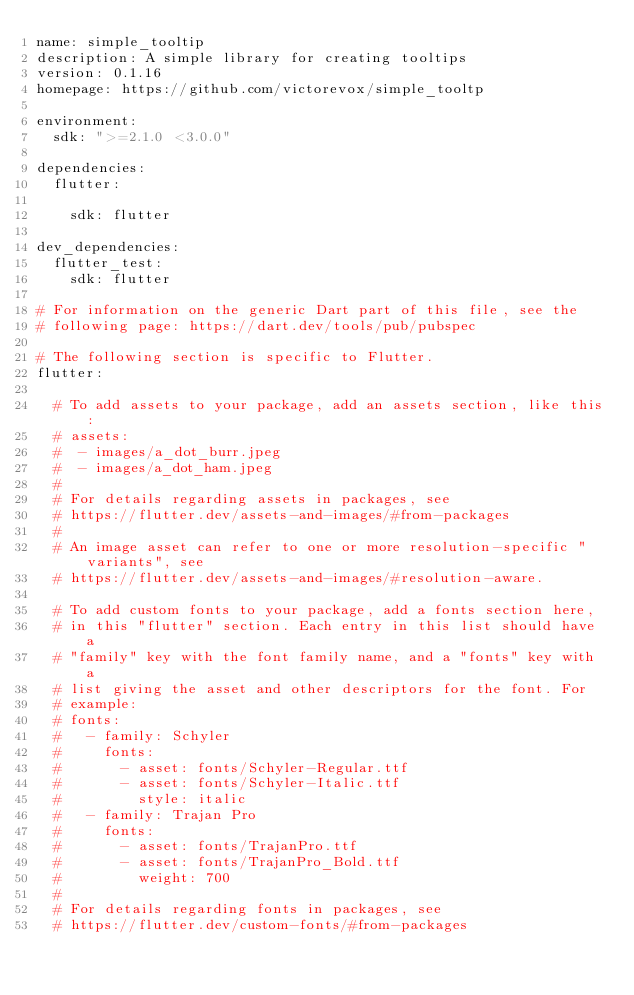Convert code to text. <code><loc_0><loc_0><loc_500><loc_500><_YAML_>name: simple_tooltip
description: A simple library for creating tooltips
version: 0.1.16
homepage: https://github.com/victorevox/simple_tooltp

environment:
  sdk: ">=2.1.0 <3.0.0"

dependencies:
  flutter:
    
    sdk: flutter

dev_dependencies:
  flutter_test:
    sdk: flutter

# For information on the generic Dart part of this file, see the
# following page: https://dart.dev/tools/pub/pubspec

# The following section is specific to Flutter.
flutter:

  # To add assets to your package, add an assets section, like this:
  # assets:
  #  - images/a_dot_burr.jpeg
  #  - images/a_dot_ham.jpeg
  #
  # For details regarding assets in packages, see
  # https://flutter.dev/assets-and-images/#from-packages
  #
  # An image asset can refer to one or more resolution-specific "variants", see
  # https://flutter.dev/assets-and-images/#resolution-aware.

  # To add custom fonts to your package, add a fonts section here,
  # in this "flutter" section. Each entry in this list should have a
  # "family" key with the font family name, and a "fonts" key with a
  # list giving the asset and other descriptors for the font. For
  # example:
  # fonts:
  #   - family: Schyler
  #     fonts:
  #       - asset: fonts/Schyler-Regular.ttf
  #       - asset: fonts/Schyler-Italic.ttf
  #         style: italic
  #   - family: Trajan Pro
  #     fonts:
  #       - asset: fonts/TrajanPro.ttf
  #       - asset: fonts/TrajanPro_Bold.ttf
  #         weight: 700
  #
  # For details regarding fonts in packages, see
  # https://flutter.dev/custom-fonts/#from-packages
</code> 